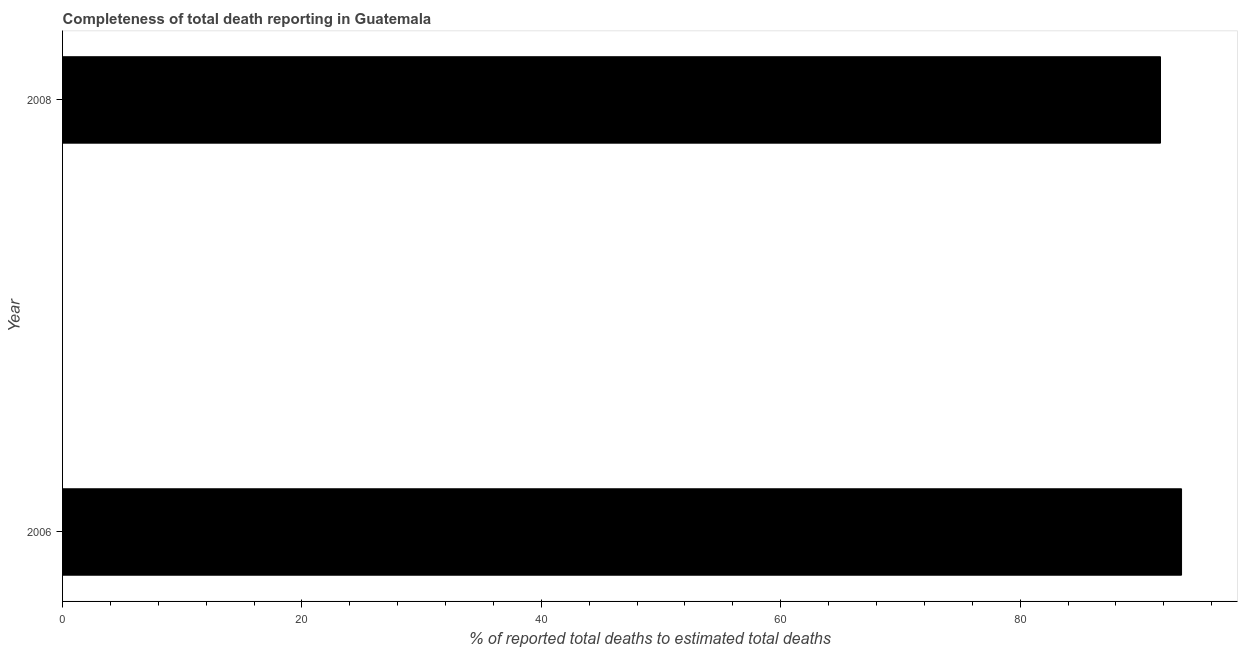Does the graph contain any zero values?
Give a very brief answer. No. Does the graph contain grids?
Give a very brief answer. No. What is the title of the graph?
Provide a short and direct response. Completeness of total death reporting in Guatemala. What is the label or title of the X-axis?
Make the answer very short. % of reported total deaths to estimated total deaths. What is the completeness of total death reports in 2006?
Make the answer very short. 93.48. Across all years, what is the maximum completeness of total death reports?
Provide a short and direct response. 93.48. Across all years, what is the minimum completeness of total death reports?
Provide a short and direct response. 91.73. In which year was the completeness of total death reports maximum?
Provide a short and direct response. 2006. What is the sum of the completeness of total death reports?
Your answer should be compact. 185.21. What is the difference between the completeness of total death reports in 2006 and 2008?
Make the answer very short. 1.76. What is the average completeness of total death reports per year?
Offer a terse response. 92.61. What is the median completeness of total death reports?
Your response must be concise. 92.61. In how many years, is the completeness of total death reports greater than 64 %?
Your answer should be very brief. 2. Do a majority of the years between 2008 and 2006 (inclusive) have completeness of total death reports greater than 32 %?
Your answer should be very brief. No. Is the completeness of total death reports in 2006 less than that in 2008?
Provide a succinct answer. No. How many bars are there?
Provide a short and direct response. 2. What is the % of reported total deaths to estimated total deaths in 2006?
Provide a succinct answer. 93.48. What is the % of reported total deaths to estimated total deaths in 2008?
Your response must be concise. 91.73. What is the difference between the % of reported total deaths to estimated total deaths in 2006 and 2008?
Your answer should be compact. 1.76. 